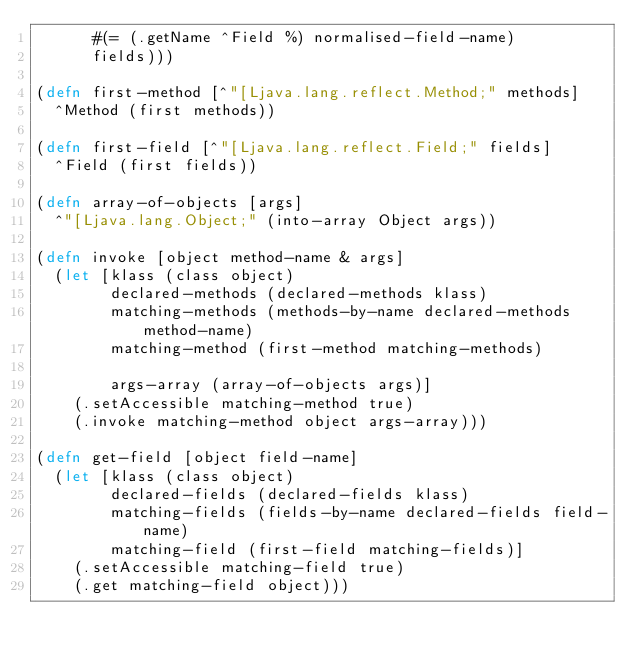<code> <loc_0><loc_0><loc_500><loc_500><_Clojure_>      #(= (.getName ^Field %) normalised-field-name)
      fields)))

(defn first-method [^"[Ljava.lang.reflect.Method;" methods]
  ^Method (first methods))

(defn first-field [^"[Ljava.lang.reflect.Field;" fields]
  ^Field (first fields))

(defn array-of-objects [args]
  ^"[Ljava.lang.Object;" (into-array Object args))

(defn invoke [object method-name & args]
  (let [klass (class object)
        declared-methods (declared-methods klass)
        matching-methods (methods-by-name declared-methods method-name)
        matching-method (first-method matching-methods)

        args-array (array-of-objects args)]
    (.setAccessible matching-method true)
    (.invoke matching-method object args-array)))

(defn get-field [object field-name]
  (let [klass (class object)
        declared-fields (declared-fields klass)
        matching-fields (fields-by-name declared-fields field-name)
        matching-field (first-field matching-fields)]
    (.setAccessible matching-field true)
    (.get matching-field object)))</code> 